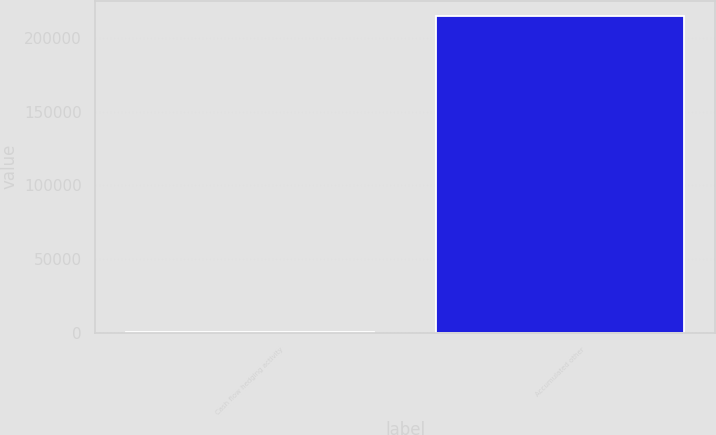Convert chart. <chart><loc_0><loc_0><loc_500><loc_500><bar_chart><fcel>Cash flow hedging activity<fcel>Accumulated other<nl><fcel>735<fcel>214776<nl></chart> 